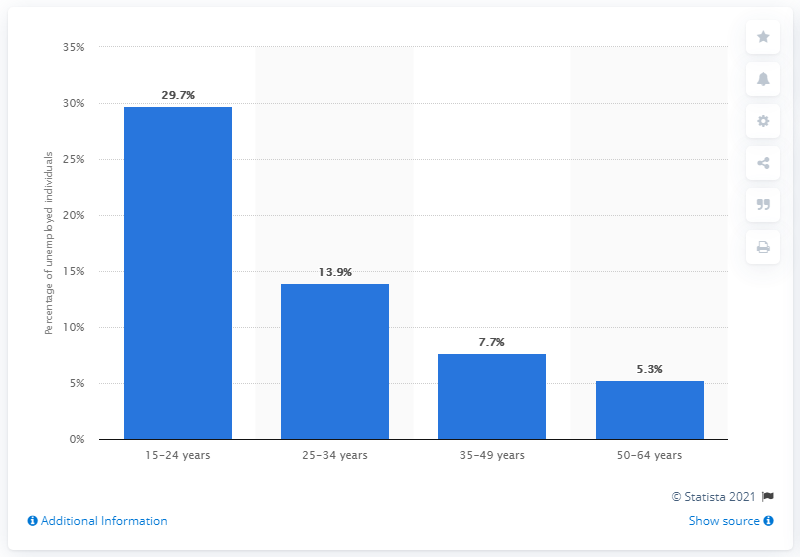Identify some key points in this picture. As of December 2020, the youth unemployment rate in Italy was 29.7%. The unemployment rate among individuals aged 15 to 24 in Italy as of December 2020 was 29.7%. 